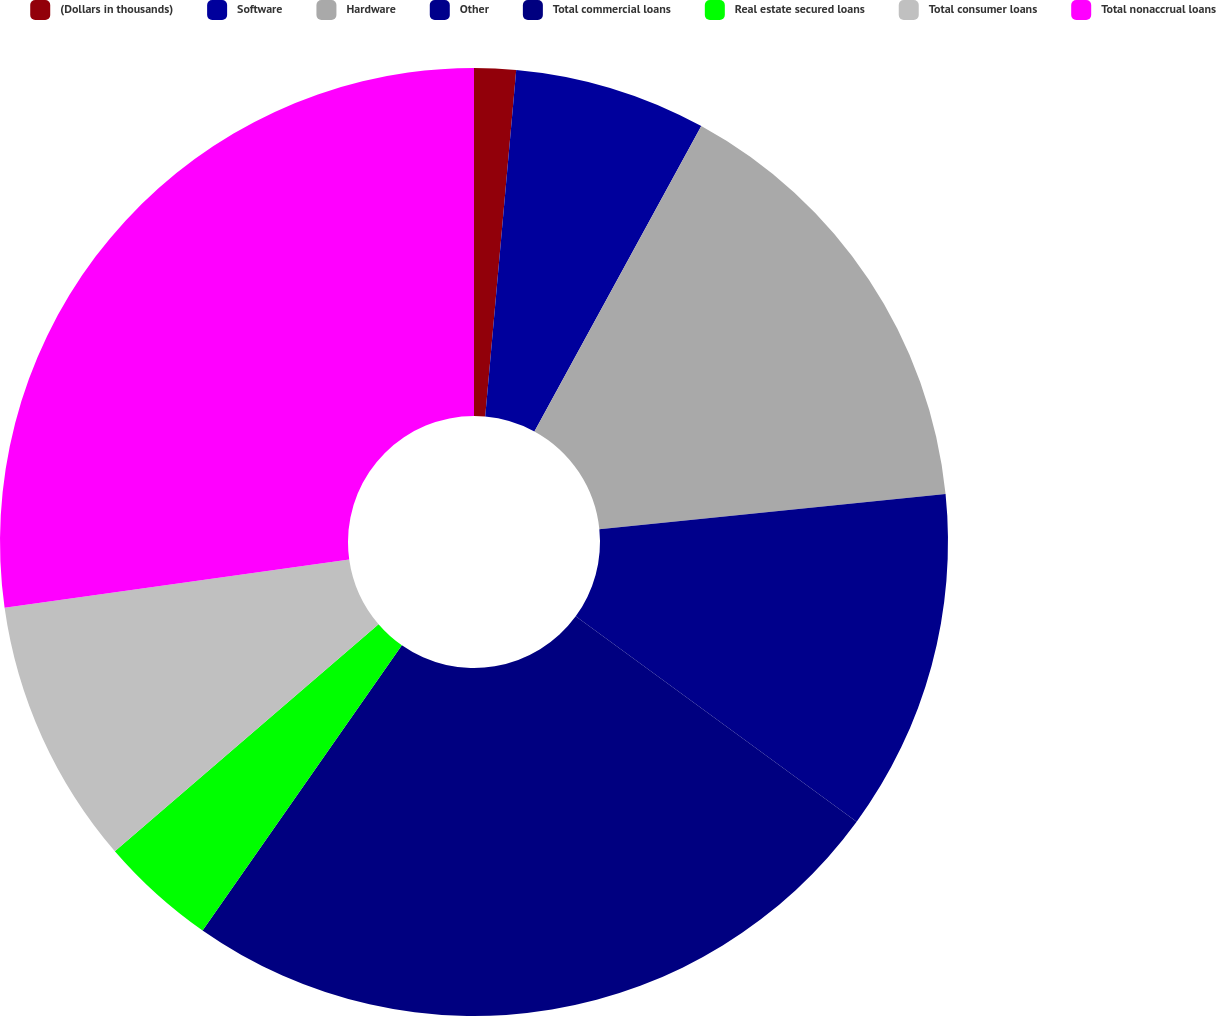Convert chart. <chart><loc_0><loc_0><loc_500><loc_500><pie_chart><fcel>(Dollars in thousands)<fcel>Software<fcel>Hardware<fcel>Other<fcel>Total commercial loans<fcel>Real estate secured loans<fcel>Total consumer loans<fcel>Total nonaccrual loans<nl><fcel>1.42%<fcel>6.54%<fcel>15.43%<fcel>11.66%<fcel>24.66%<fcel>3.98%<fcel>9.1%<fcel>27.22%<nl></chart> 